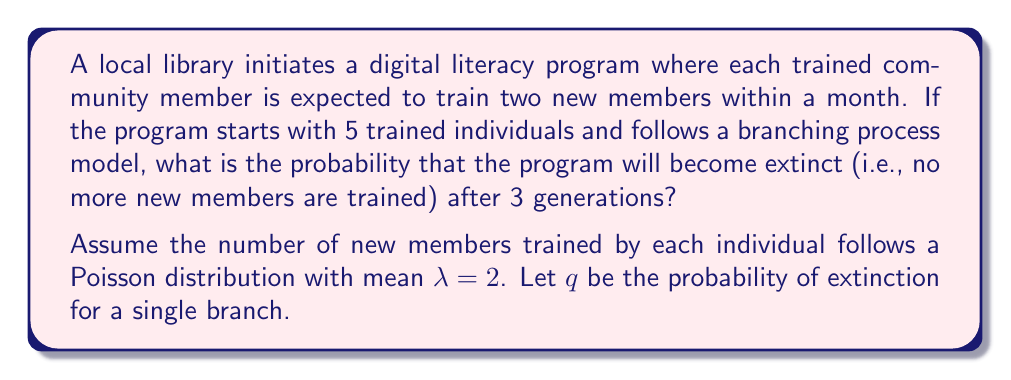Give your solution to this math problem. To solve this problem, we'll follow these steps:

1) First, we need to find the probability of extinction for a single branch (q). In a branching process with Poisson offspring distribution:

   $$q = e^{-\lambda(1-q)}$$

   Where $\lambda = 2$ in our case.

2) We can solve this equation numerically:

   $$q = e^{-2(1-q)}$$

   Using iteration or a numerical solver, we find that $q \approx 0.2032$.

3) Now, for the entire program to become extinct after 3 generations, all 5 initial branches must become extinct within 3 generations.

4) The probability of extinction for a single branch after 3 generations is:

   $$q_3 = q + pq + p^2q = q + (1-q)q + (1-q)^2q = q(3-3q+q^2)$$

   Where $p = 1-q$ is the probability of survival for one generation.

5) Substituting our value of $q$:

   $$q_3 = 0.2032(3-3(0.2032)+0.2032^2) \approx 0.5404$$

6) For all 5 initial branches to become extinct, we raise this probability to the 5th power:

   $$P(\text{extinction}) = (q_3)^5 \approx (0.5404)^5 \approx 0.0491$$

Therefore, the probability that the program will become extinct after 3 generations is approximately 0.0491 or 4.91%.
Answer: 0.0491 